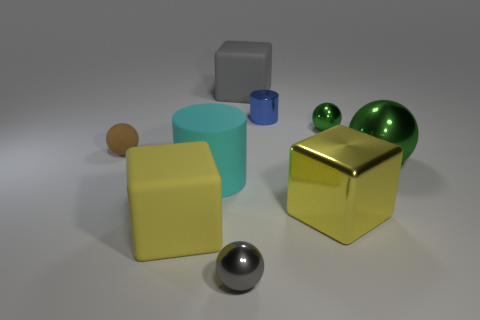There is a yellow matte object that is the same shape as the gray matte object; what is its size?
Make the answer very short. Large. Does the blue object have the same material as the cyan cylinder?
Ensure brevity in your answer.  No. Is the number of large blocks that are on the right side of the blue metallic thing less than the number of brown rubber cylinders?
Ensure brevity in your answer.  No. What is the shape of the small green object that is made of the same material as the tiny gray object?
Keep it short and to the point. Sphere. What number of matte blocks are the same color as the metal cube?
Offer a terse response. 1. How many objects are either large yellow matte things or yellow cubes?
Provide a short and direct response. 2. What material is the big yellow thing left of the cube that is behind the blue cylinder?
Provide a succinct answer. Rubber. Is there a yellow object that has the same material as the small gray sphere?
Provide a succinct answer. Yes. The large yellow object that is behind the large yellow thing to the left of the matte block that is behind the big cyan matte cylinder is what shape?
Provide a short and direct response. Cube. What is the big gray thing made of?
Provide a succinct answer. Rubber. 